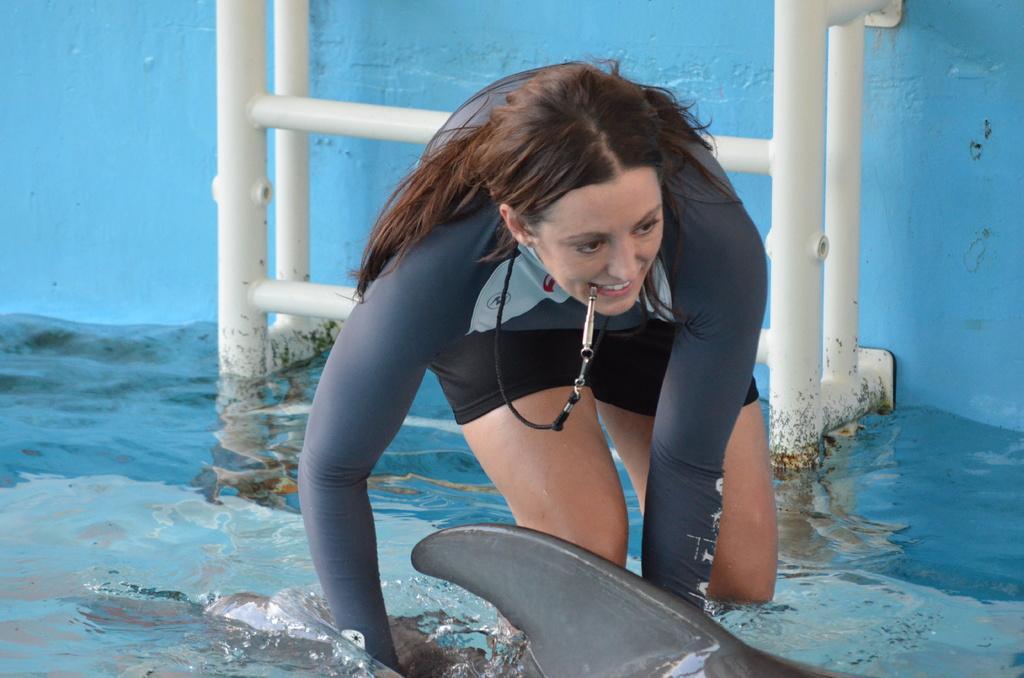In one or two sentences, can you explain what this image depicts? In this picture there is a lady at the center of the image, this picture is taken in the water and there is a ladder behind the lady and the lady is trying to catch the fish. 